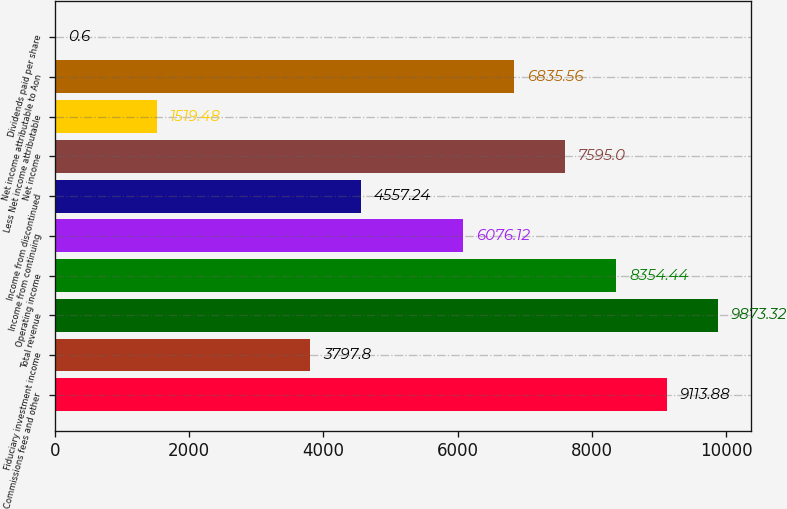<chart> <loc_0><loc_0><loc_500><loc_500><bar_chart><fcel>Commissions fees and other<fcel>Fiduciary investment income<fcel>Total revenue<fcel>Operating income<fcel>Income from continuing<fcel>Income from discontinued<fcel>Net income<fcel>Less Net income attributable<fcel>Net income attributable to Aon<fcel>Dividends paid per share<nl><fcel>9113.88<fcel>3797.8<fcel>9873.32<fcel>8354.44<fcel>6076.12<fcel>4557.24<fcel>7595<fcel>1519.48<fcel>6835.56<fcel>0.6<nl></chart> 